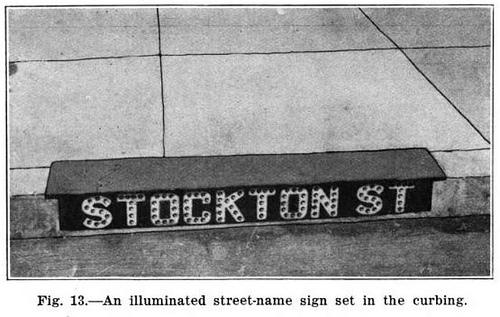What does this say?
Keep it brief. Stockton st. Are there numbers in this picture?
Be succinct. No. What is the figure number?
Be succinct. 13. 